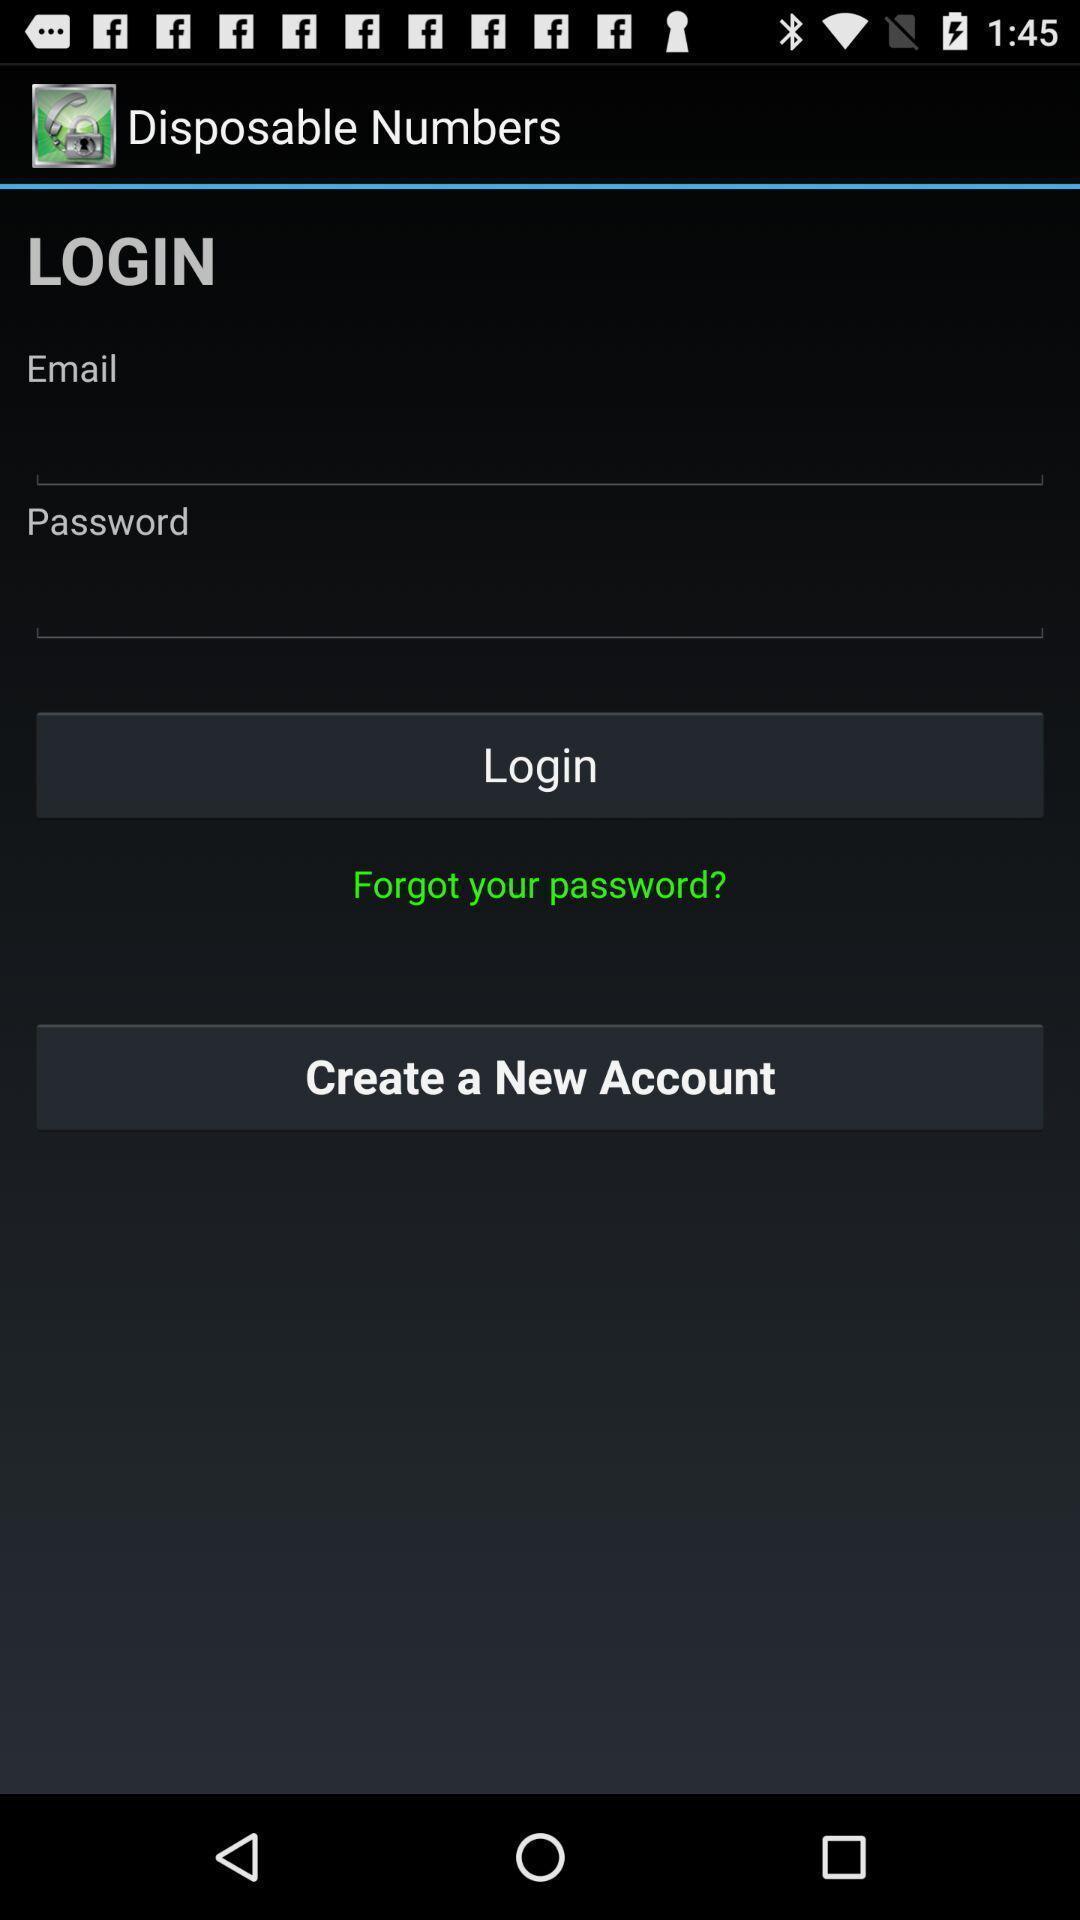Tell me about the visual elements in this screen capture. Page showing login page. 